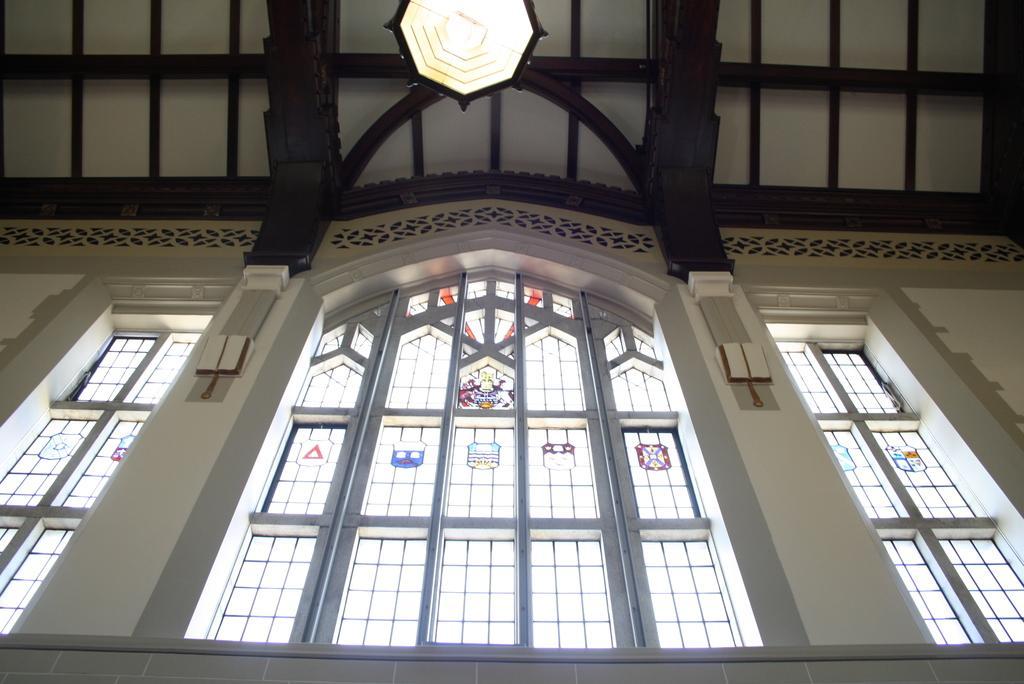Can you describe this image briefly? This is an inside view of a building and here we can see windows, a light and at the top, there is a roof. 